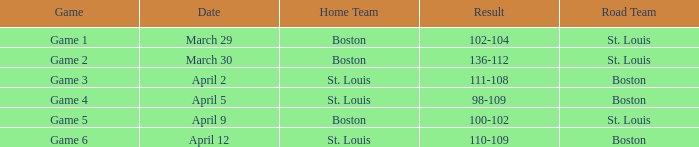In what game was the outcome 136-112? Game 2. 